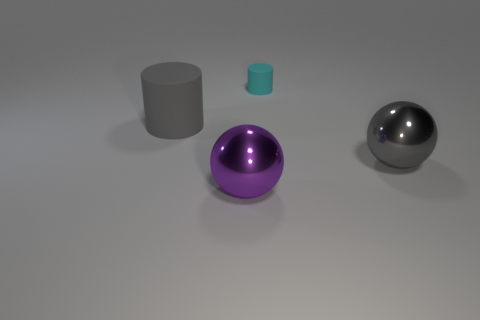Add 1 tiny cyan rubber things. How many objects exist? 5 Subtract all brown cylinders. Subtract all blue spheres. How many cylinders are left? 2 Add 4 cyan matte objects. How many cyan matte objects exist? 5 Subtract 0 purple cylinders. How many objects are left? 4 Subtract all shiny objects. Subtract all gray matte cylinders. How many objects are left? 1 Add 4 big gray metallic objects. How many big gray metallic objects are left? 5 